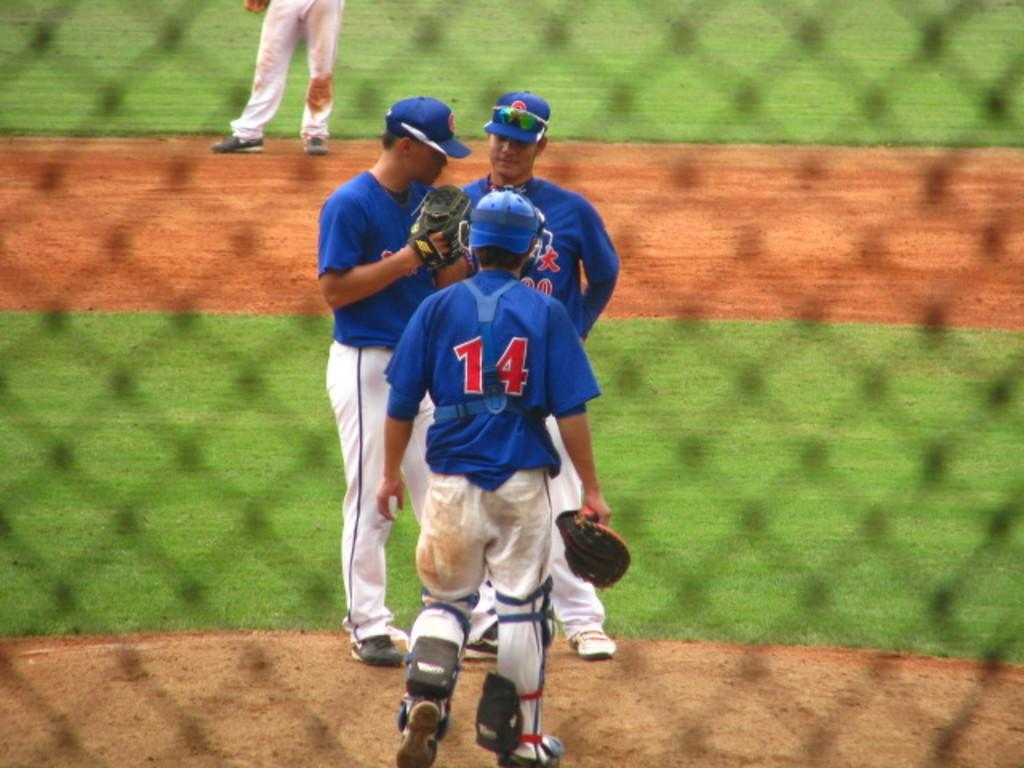<image>
Relay a brief, clear account of the picture shown. The catcher wearing number 14 is at the mound talking with the pitcher and coach. 